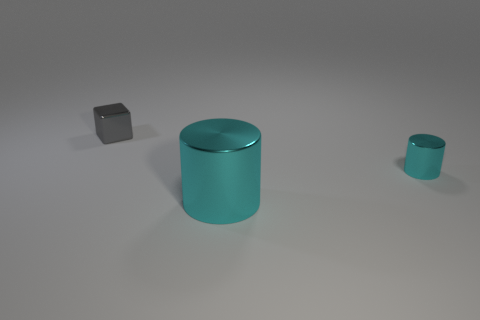Add 3 purple blocks. How many objects exist? 6 Subtract all blocks. How many objects are left? 2 Add 1 cyan objects. How many cyan objects are left? 3 Add 1 gray objects. How many gray objects exist? 2 Subtract 0 cyan blocks. How many objects are left? 3 Subtract all large cyan shiny cylinders. Subtract all big cyan cylinders. How many objects are left? 1 